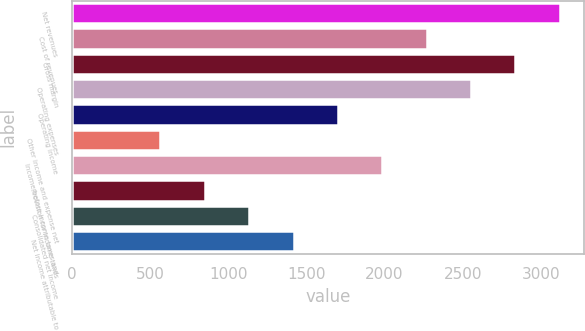Convert chart to OTSL. <chart><loc_0><loc_0><loc_500><loc_500><bar_chart><fcel>Net revenues<fcel>Cost of revenues<fcel>Gross margin<fcel>Operating expenses<fcel>Operating income<fcel>Other income and expense net<fcel>Income before income taxes and<fcel>Provision for income taxes<fcel>Consolidated net income<fcel>Net income attributable to<nl><fcel>3119.67<fcel>2269.02<fcel>2836.12<fcel>2552.57<fcel>1701.92<fcel>567.72<fcel>1985.47<fcel>851.27<fcel>1134.82<fcel>1418.37<nl></chart> 